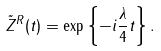<formula> <loc_0><loc_0><loc_500><loc_500>\tilde { Z } ^ { R } ( t ) = \exp \left \{ - i \frac { \lambda } { 4 } t \right \} .</formula> 